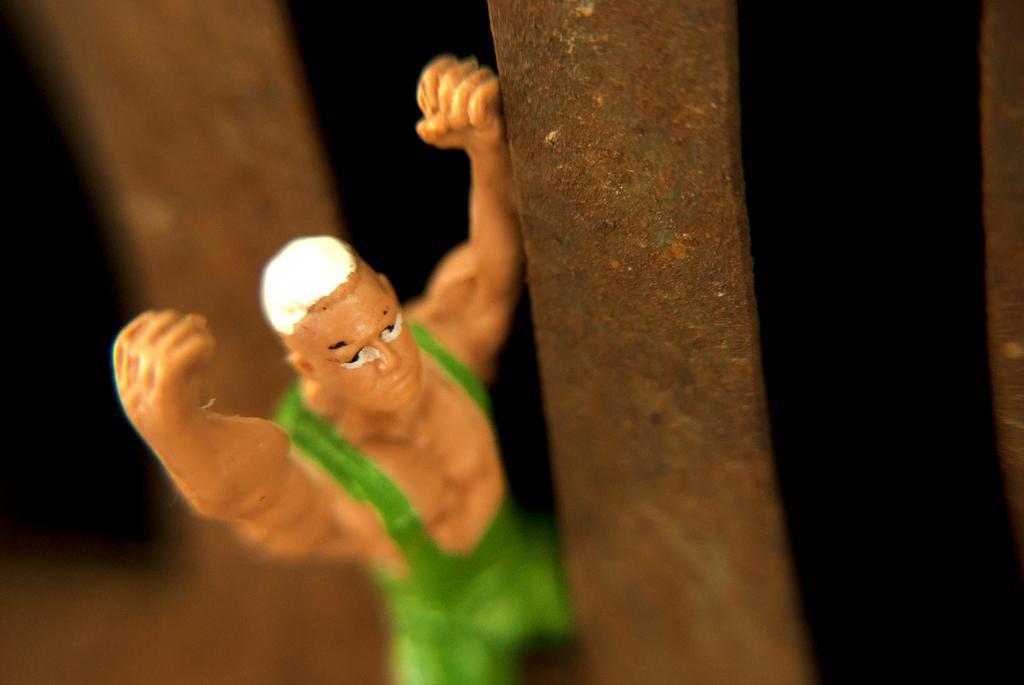Can you describe this image briefly? In this image we can see a toy and the background is dark and blurred. 